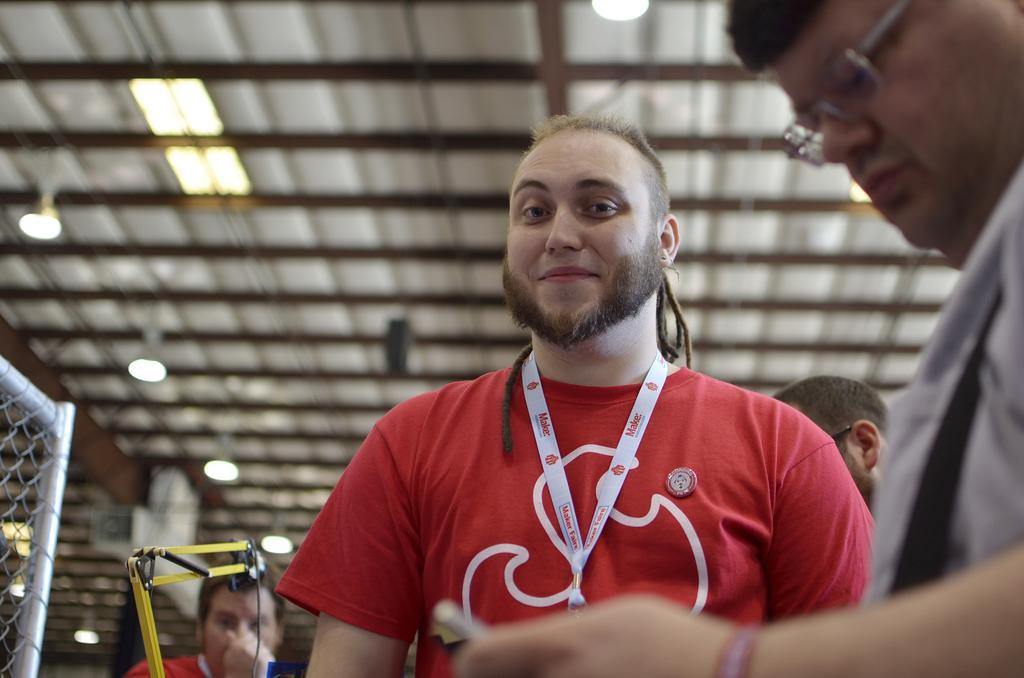In one or two sentences, can you explain what this image depicts? In this image, we can see a person is watching and smiling. Background there is a blur view. On the right side and left side, we can see people. Here we can see a person's head. Here there are few lights, rods, mesh and few objects. 